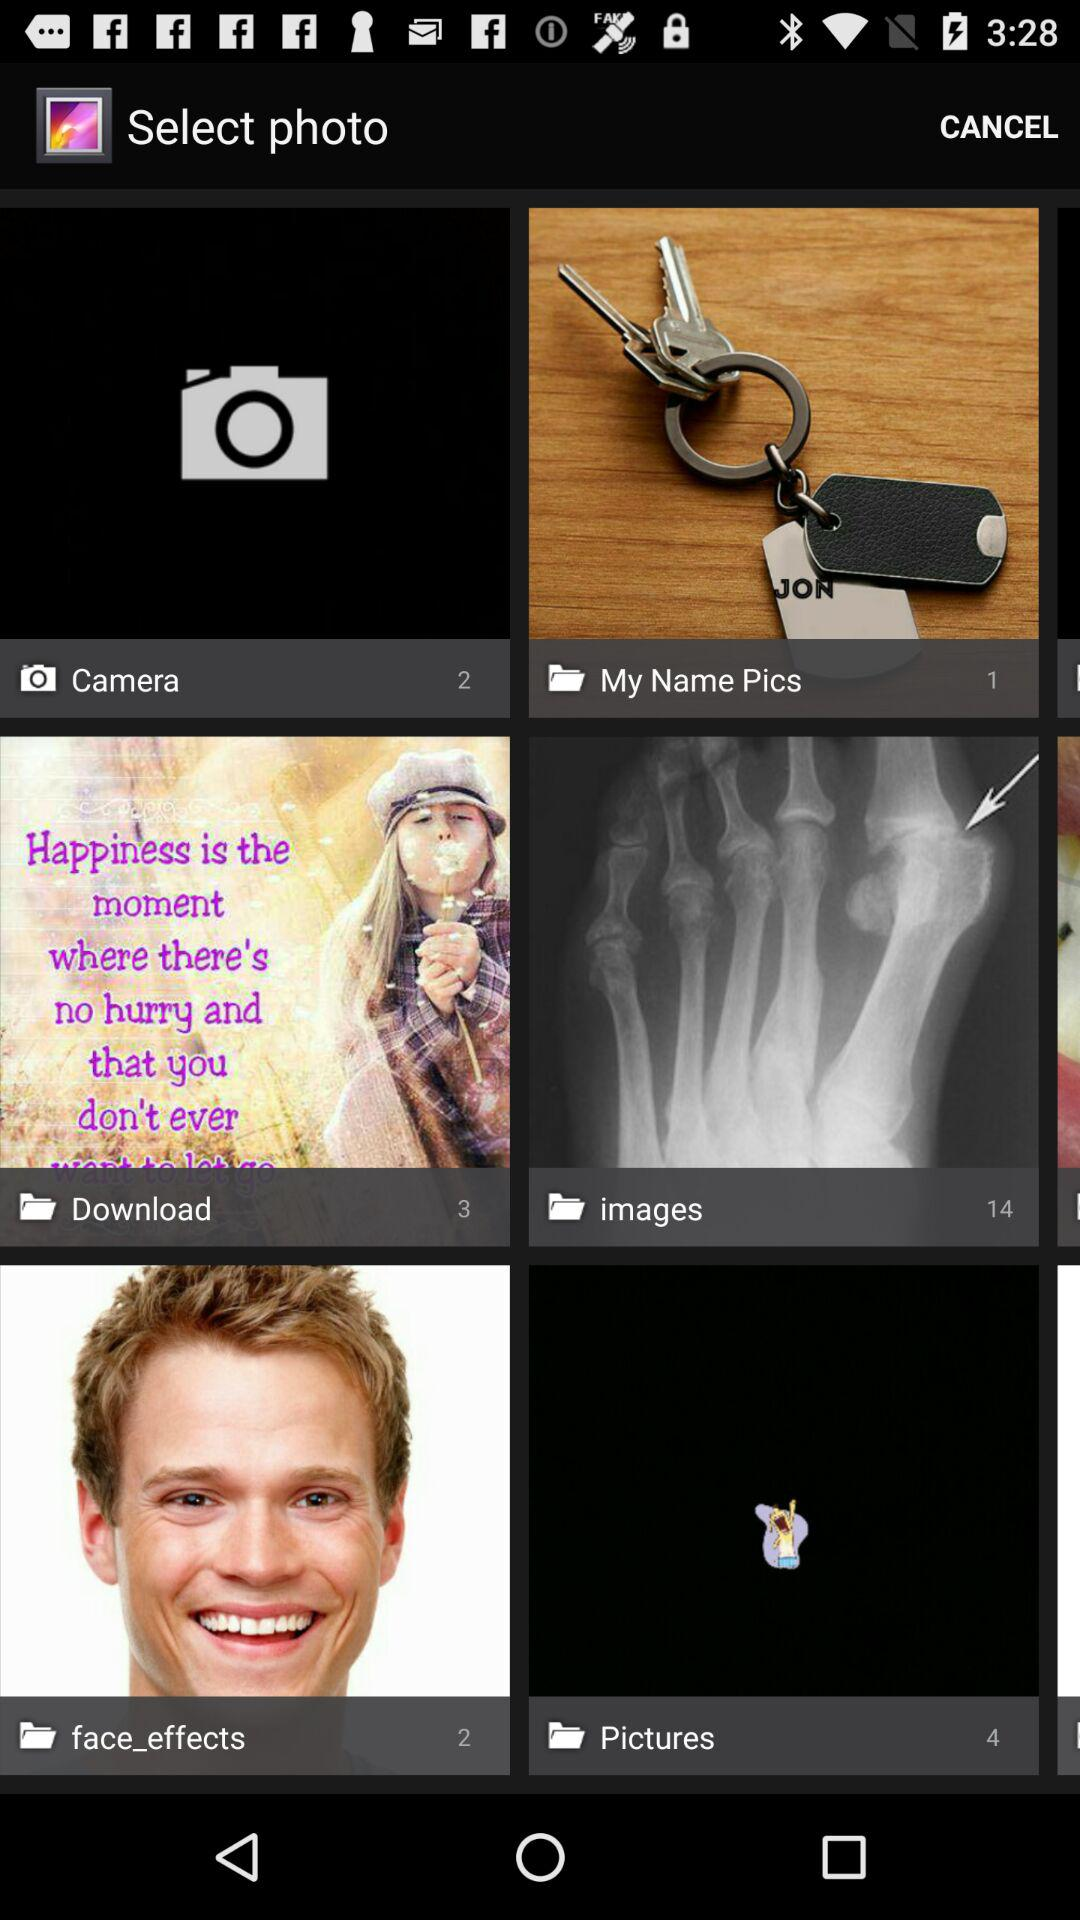How many photos are there in the "Download" folder? There are 3 photos. 